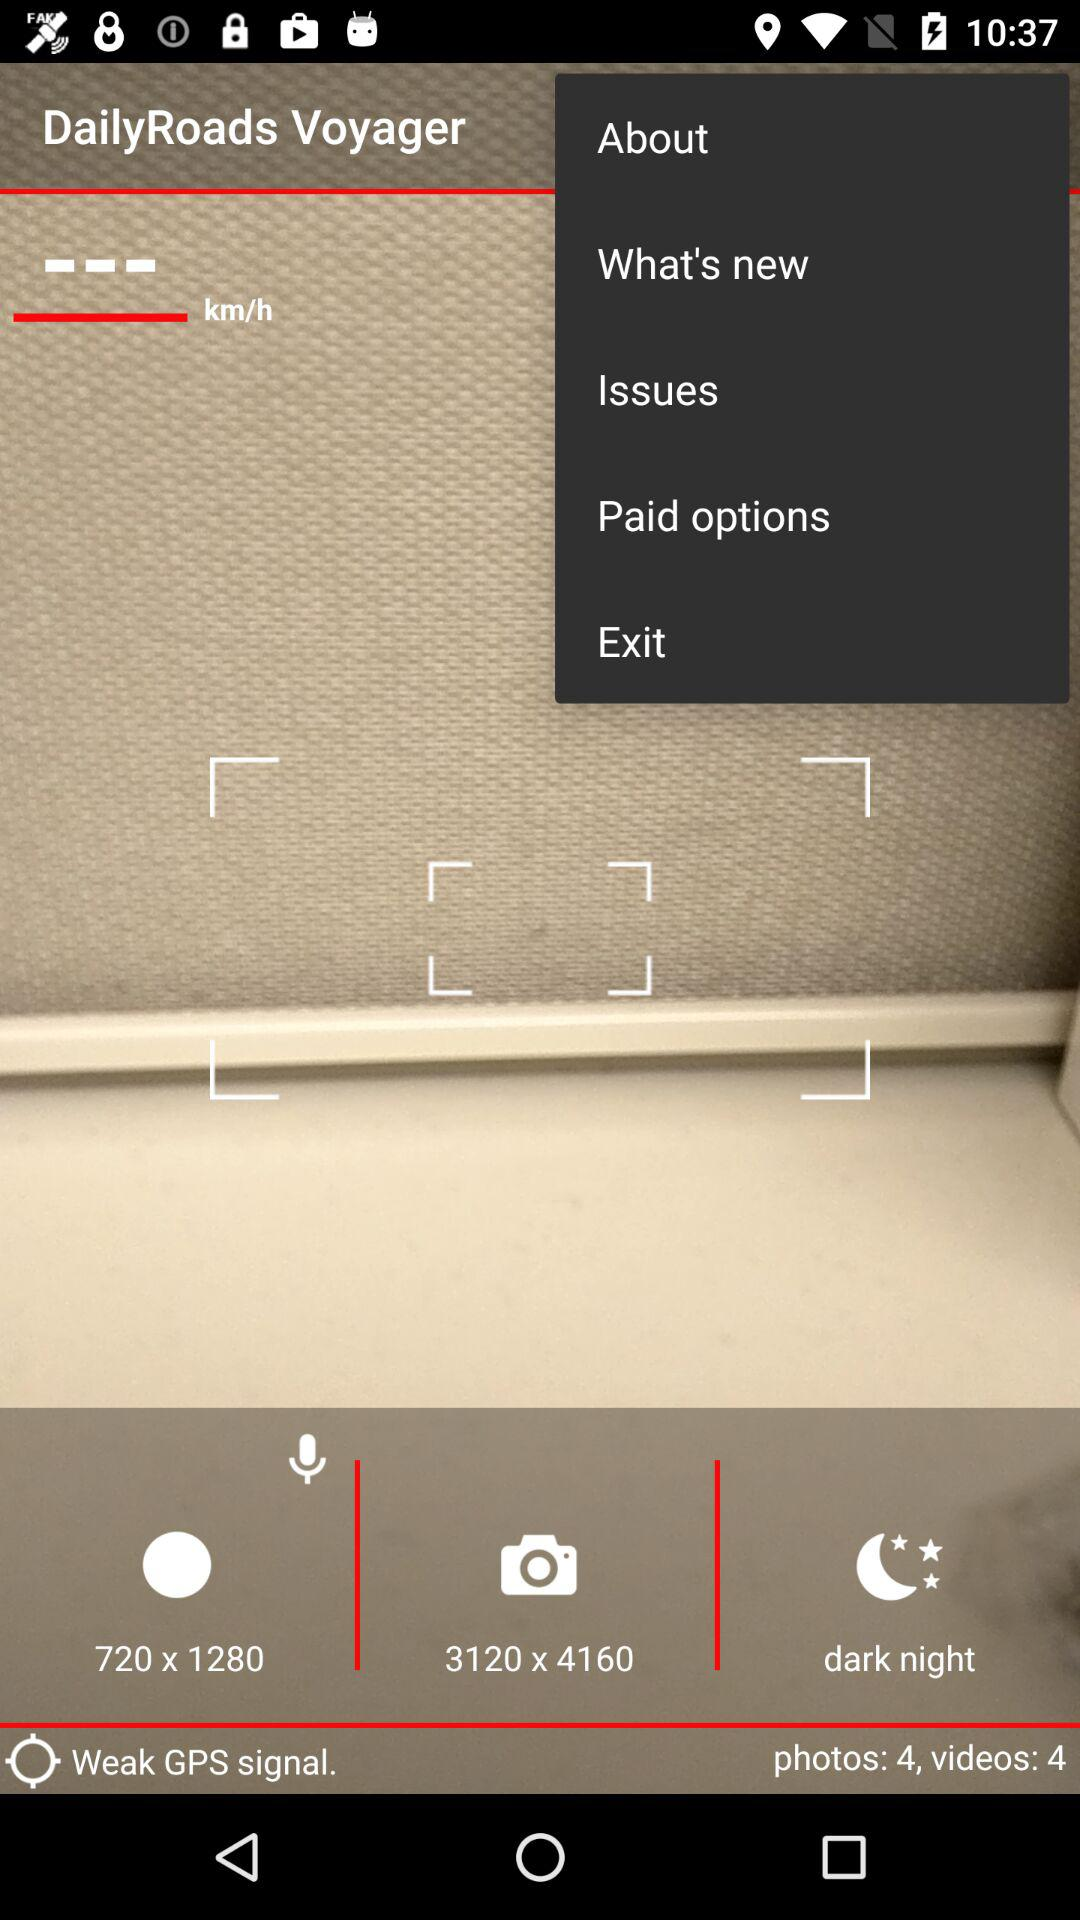What is the total number of videos? The total number of videos is 4. 